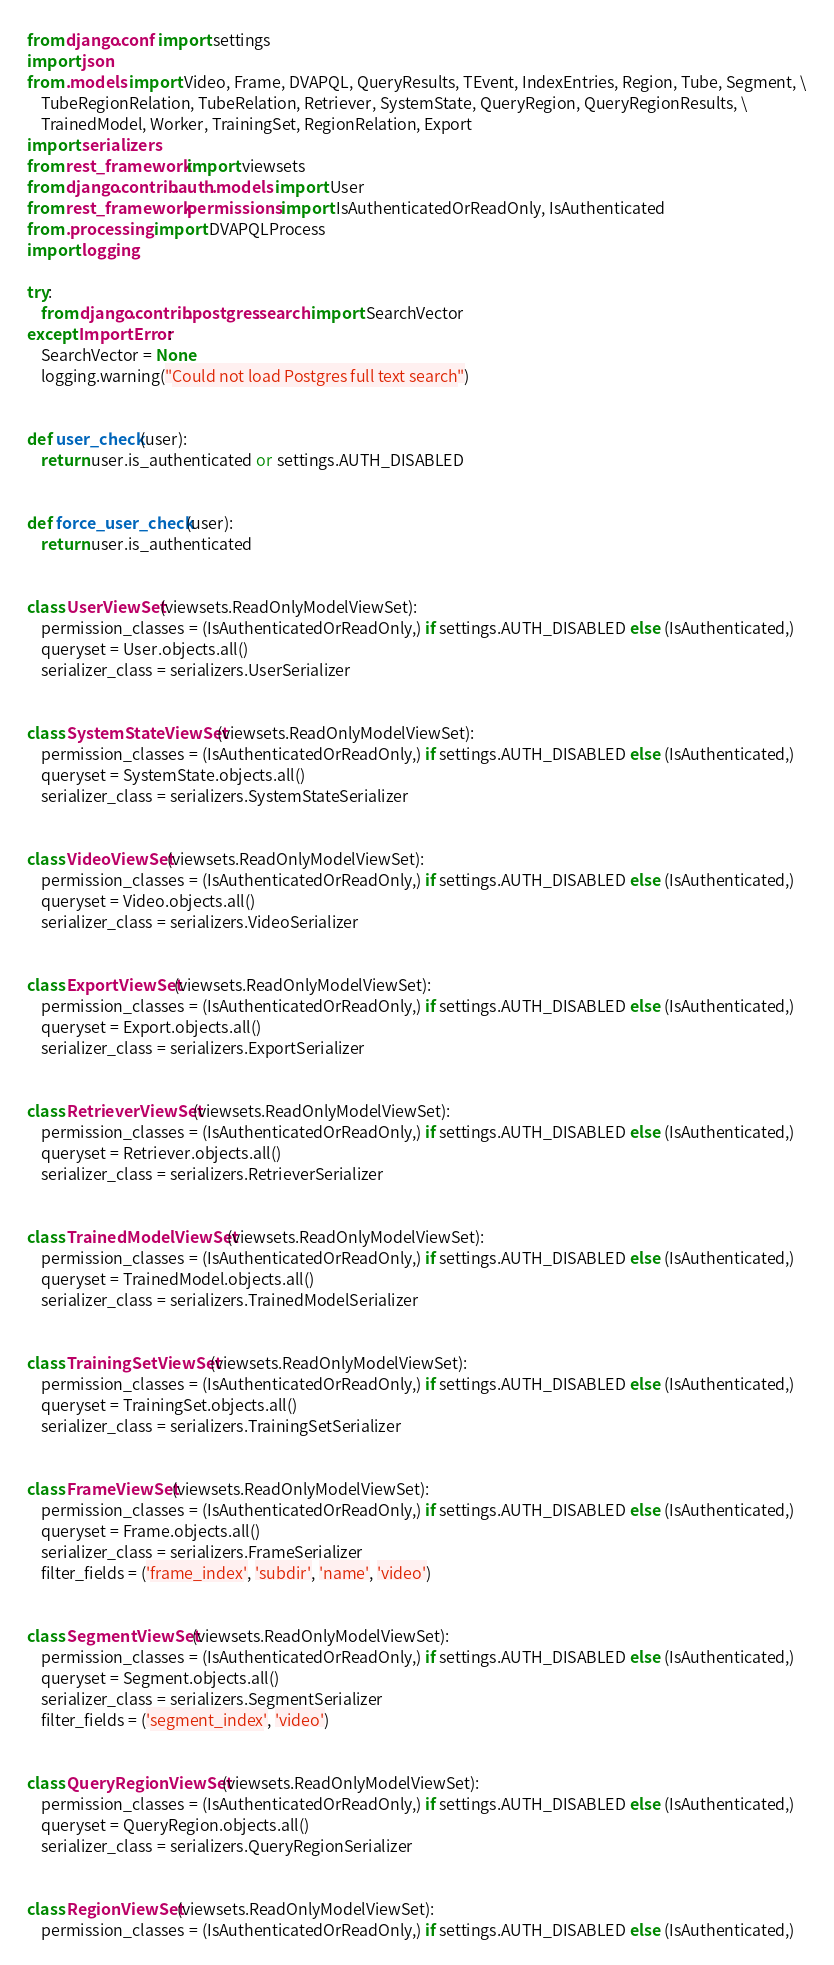Convert code to text. <code><loc_0><loc_0><loc_500><loc_500><_Python_>from django.conf import settings
import json
from .models import Video, Frame, DVAPQL, QueryResults, TEvent, IndexEntries, Region, Tube, Segment, \
    TubeRegionRelation, TubeRelation, Retriever, SystemState, QueryRegion, QueryRegionResults, \
    TrainedModel, Worker, TrainingSet, RegionRelation, Export
import serializers
from rest_framework import viewsets
from django.contrib.auth.models import User
from rest_framework.permissions import IsAuthenticatedOrReadOnly, IsAuthenticated
from .processing import DVAPQLProcess
import logging

try:
    from django.contrib.postgres.search import SearchVector
except ImportError:
    SearchVector = None
    logging.warning("Could not load Postgres full text search")


def user_check(user):
    return user.is_authenticated or settings.AUTH_DISABLED


def force_user_check(user):
    return user.is_authenticated


class UserViewSet(viewsets.ReadOnlyModelViewSet):
    permission_classes = (IsAuthenticatedOrReadOnly,) if settings.AUTH_DISABLED else (IsAuthenticated,)
    queryset = User.objects.all()
    serializer_class = serializers.UserSerializer


class SystemStateViewSet(viewsets.ReadOnlyModelViewSet):
    permission_classes = (IsAuthenticatedOrReadOnly,) if settings.AUTH_DISABLED else (IsAuthenticated,)
    queryset = SystemState.objects.all()
    serializer_class = serializers.SystemStateSerializer


class VideoViewSet(viewsets.ReadOnlyModelViewSet):
    permission_classes = (IsAuthenticatedOrReadOnly,) if settings.AUTH_DISABLED else (IsAuthenticated,)
    queryset = Video.objects.all()
    serializer_class = serializers.VideoSerializer


class ExportViewSet(viewsets.ReadOnlyModelViewSet):
    permission_classes = (IsAuthenticatedOrReadOnly,) if settings.AUTH_DISABLED else (IsAuthenticated,)
    queryset = Export.objects.all()
    serializer_class = serializers.ExportSerializer


class RetrieverViewSet(viewsets.ReadOnlyModelViewSet):
    permission_classes = (IsAuthenticatedOrReadOnly,) if settings.AUTH_DISABLED else (IsAuthenticated,)
    queryset = Retriever.objects.all()
    serializer_class = serializers.RetrieverSerializer


class TrainedModelViewSet(viewsets.ReadOnlyModelViewSet):
    permission_classes = (IsAuthenticatedOrReadOnly,) if settings.AUTH_DISABLED else (IsAuthenticated,)
    queryset = TrainedModel.objects.all()
    serializer_class = serializers.TrainedModelSerializer


class TrainingSetViewSet(viewsets.ReadOnlyModelViewSet):
    permission_classes = (IsAuthenticatedOrReadOnly,) if settings.AUTH_DISABLED else (IsAuthenticated,)
    queryset = TrainingSet.objects.all()
    serializer_class = serializers.TrainingSetSerializer


class FrameViewSet(viewsets.ReadOnlyModelViewSet):
    permission_classes = (IsAuthenticatedOrReadOnly,) if settings.AUTH_DISABLED else (IsAuthenticated,)
    queryset = Frame.objects.all()
    serializer_class = serializers.FrameSerializer
    filter_fields = ('frame_index', 'subdir', 'name', 'video')


class SegmentViewSet(viewsets.ReadOnlyModelViewSet):
    permission_classes = (IsAuthenticatedOrReadOnly,) if settings.AUTH_DISABLED else (IsAuthenticated,)
    queryset = Segment.objects.all()
    serializer_class = serializers.SegmentSerializer
    filter_fields = ('segment_index', 'video')


class QueryRegionViewSet(viewsets.ReadOnlyModelViewSet):
    permission_classes = (IsAuthenticatedOrReadOnly,) if settings.AUTH_DISABLED else (IsAuthenticated,)
    queryset = QueryRegion.objects.all()
    serializer_class = serializers.QueryRegionSerializer


class RegionViewSet(viewsets.ReadOnlyModelViewSet):
    permission_classes = (IsAuthenticatedOrReadOnly,) if settings.AUTH_DISABLED else (IsAuthenticated,)</code> 